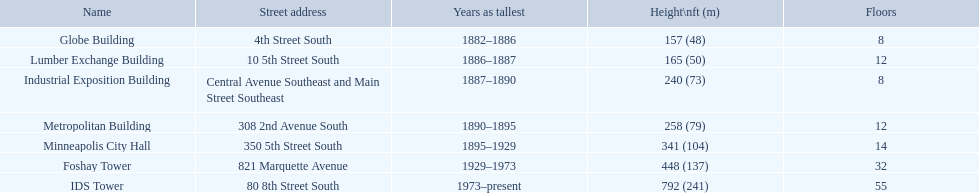Which structures possess an equal amount of floors as another structure? Globe Building, Lumber Exchange Building, Industrial Exposition Building, Metropolitan Building. Among them, which one shares the same number as the lumber exchange building? Metropolitan Building. 